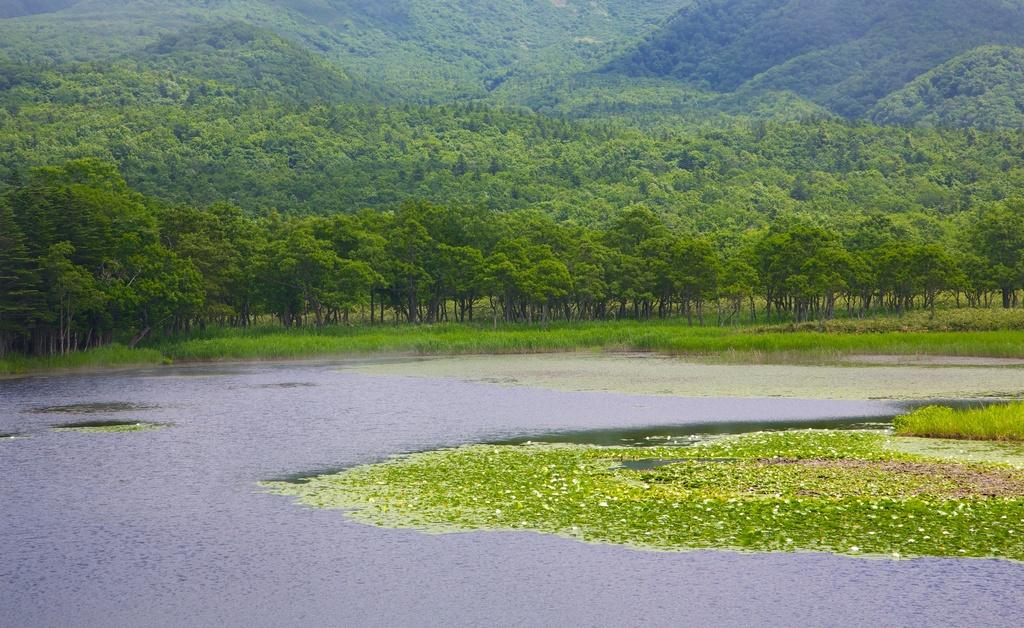What is present on the river in the image? There are leaves on the river in the image. What type of vegetation can be seen in the background of the image? There is grass visible in the background of the image. What else is present in the background of the image? There are trees present in the background of the image. How many fish can be seen swimming in the river in the image? There are no fish visible in the image; it only features leaves on the river. What type of creature is shown walking on the grass in the image? There is no creature shown walking on the grass in the image; it only features grass and trees in the background. 